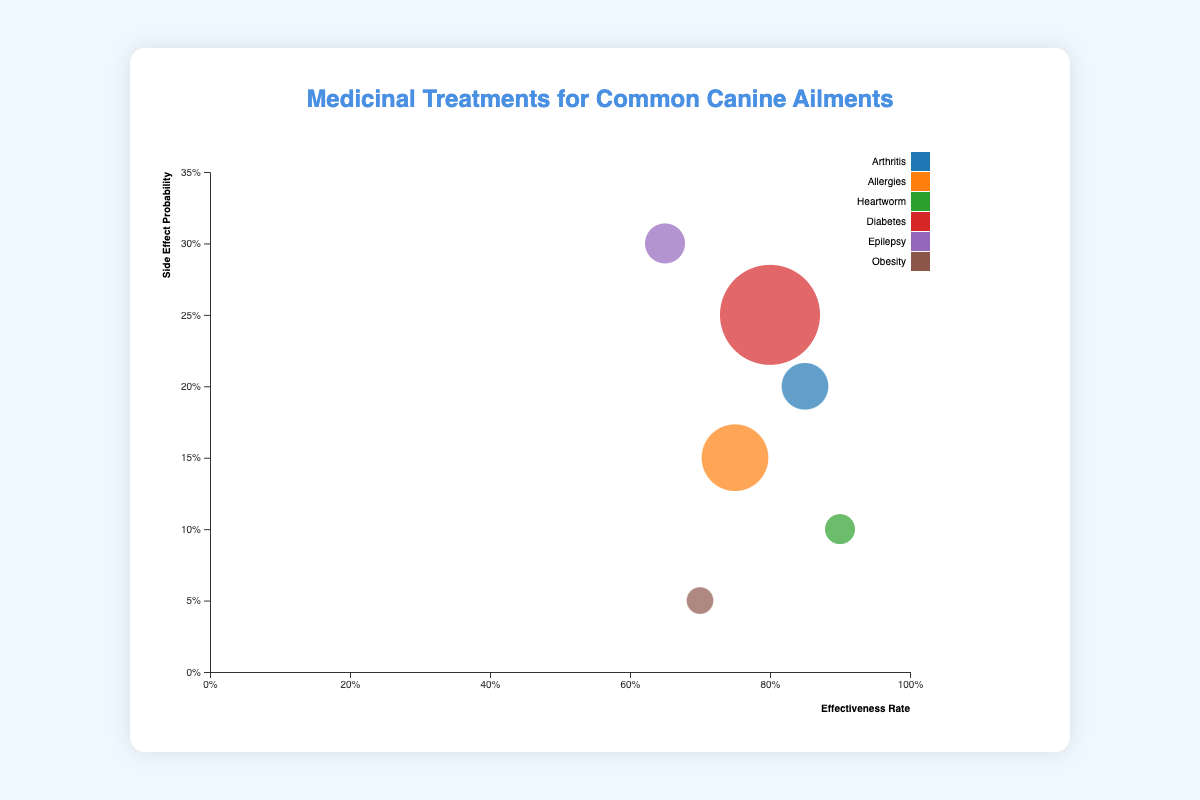How many data points are represented in the chart? By counting the number of bubbles in the chart, we can identify the total number of data points represented.
Answer: 6 Which medication has the highest effectiveness rate? By examining the x-axis which represents effectiveness rate and locating the bubble farthest to the right, we can determine the medication with the highest effectiveness.
Answer: Ivermectin What is the average cost per year for treating Epilepsy? By identifying the bubble labeled with Epilepsy and looking at its tooltip or details, it's possible to find the average cost per year.
Answer: 300 Which ailment has the lowest side effect probability? By examining the y-axis which represents side effect probability and locating the bubble closest to the bottom, we can find the ailment with the lowest side effect probability.
Answer: Obesity Rank the medications based on their effectiveness rate from highest to lowest. By examining the x-axis values for effectiveness rate and ordering the bubbles accordingly, we can rank the medications.
Answer: Ivermectin, Carprofen, Insulin, Apoquel, Thyroxine, Phenobarbital Which ailment has the highest average cost per year for its treatment? By examining the size of the bubbles, which represent average cost per year, and identifying the largest bubble, we can determine the ailment with the highest average cost per year.
Answer: Diabetes Compare the effectiveness rate of Carprofen and Apoquel. Which one is higher? By locating the bubbles for Carprofen and Apoquel on the x-axis, we can compare their positions to determine which one is higher.
Answer: Carprofen What is the effectiveness rate difference between Insulin and Phenobarbital? By subtracting the x-axis value of the effectiveness rate of Phenobarbital from that of Insulin, we can find the difference.
Answer: 0.15 Which ailments' medications have a side effect probability of 0.2 or higher? By examining the y-axis values and identifying bubbles at or above the 0.2 mark, we can identify the relevant ailments.
Answer: Arthritis, Diabetes, Epilepsy If the side effect probability is below 0.1, which medications fit this criterion? By identifying bubbles positioned below the 0.1 mark on the y-axis, we can determine the medications fitting this criterion.
Answer: Thyroxine 